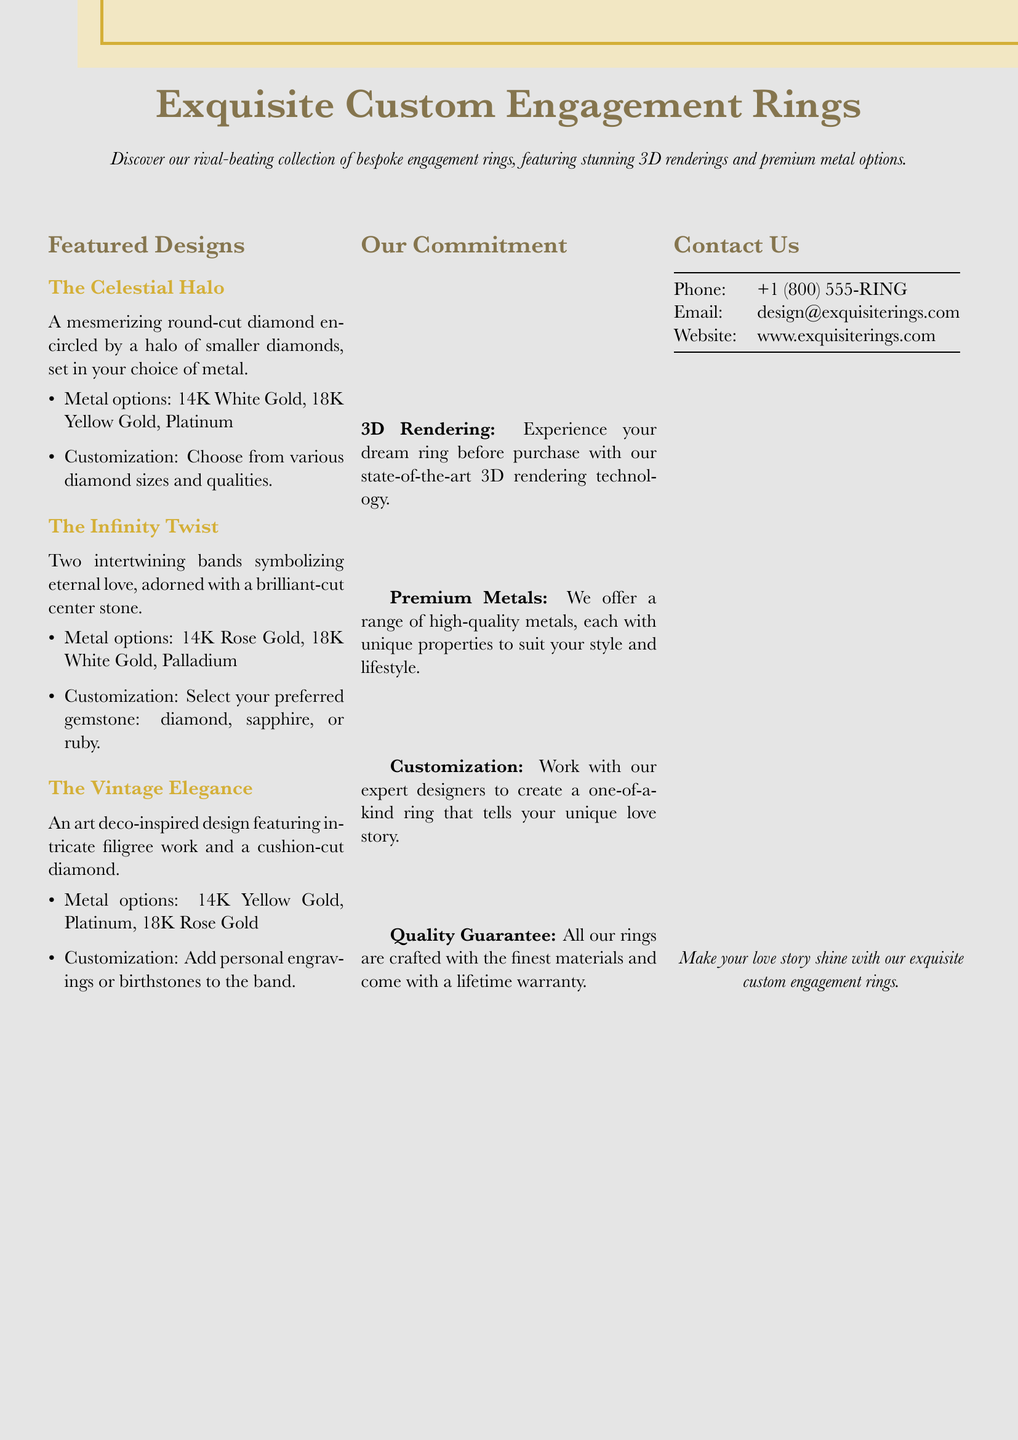What is the name of the first featured design? The first featured design is mentioned as "The Celestial Halo".
Answer: The Celestial Halo How many metal options are available for The Infinity Twist? The Infinity Twist offers three metal options: 14K Rose Gold, 18K White Gold, and Palladium.
Answer: 3 What customization options are available for The Vintage Elegance? The customization options for The Vintage Elegance include adding personal engravings or birthstones to the band.
Answer: Personal engravings or birthstones What technology is used to visualize the rings before purchase? The document states that state-of-the-art 3D rendering technology is used to experience the rings before purchase.
Answer: 3D rendering What is the warranty period mentioned for the rings? The document mentions a lifetime warranty for all the rings.
Answer: Lifetime What gemstone options can be chosen for The Infinity Twist? The Infinity Twist allows the selection of a diamond, sapphire, or ruby as gemstone options.
Answer: Diamond, sapphire, or ruby Which metal option is not listed for The Celestial Halo? The metal options for The Celestial Halo do not include 18K Rose Gold.
Answer: 18K Rose Gold What is the contact email provided in the document? The contact email listed is "design@exquisiterings.com".
Answer: design@exquisiterings.com What type of design inspiration does The Vintage Elegance feature? The Vintage Elegance is inspired by art deco design.
Answer: Art deco 